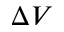<formula> <loc_0><loc_0><loc_500><loc_500>\Delta V</formula> 